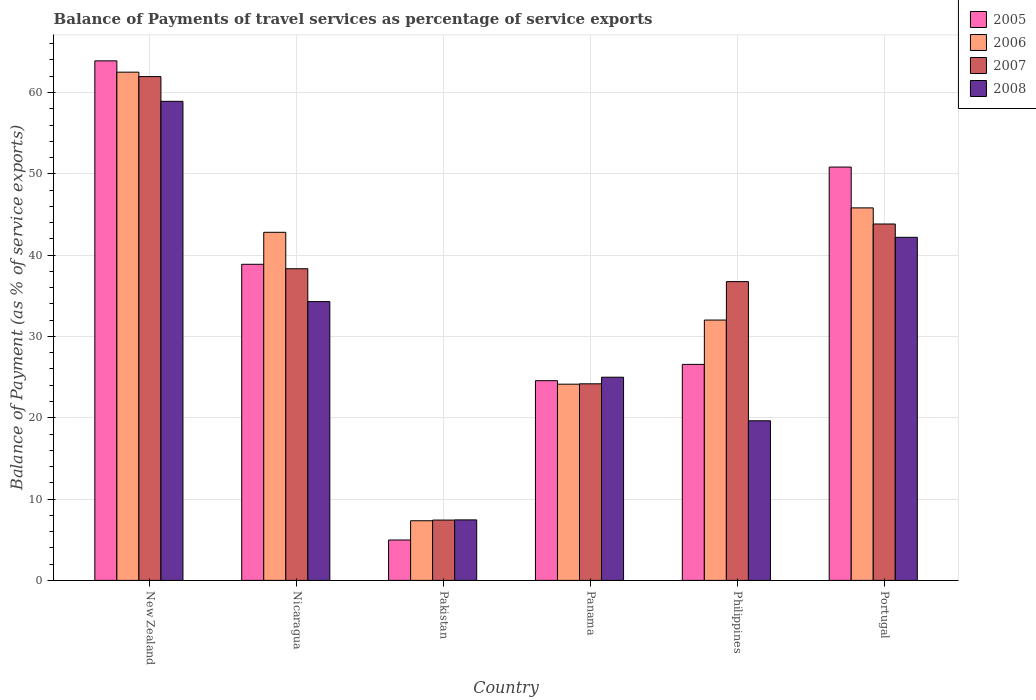How many different coloured bars are there?
Your answer should be very brief. 4. What is the label of the 3rd group of bars from the left?
Provide a short and direct response. Pakistan. In how many cases, is the number of bars for a given country not equal to the number of legend labels?
Provide a short and direct response. 0. What is the balance of payments of travel services in 2007 in Pakistan?
Your response must be concise. 7.42. Across all countries, what is the maximum balance of payments of travel services in 2008?
Ensure brevity in your answer.  58.91. Across all countries, what is the minimum balance of payments of travel services in 2006?
Provide a short and direct response. 7.34. In which country was the balance of payments of travel services in 2006 maximum?
Keep it short and to the point. New Zealand. What is the total balance of payments of travel services in 2007 in the graph?
Provide a succinct answer. 212.45. What is the difference between the balance of payments of travel services in 2006 in New Zealand and that in Panama?
Provide a short and direct response. 38.37. What is the difference between the balance of payments of travel services in 2008 in Panama and the balance of payments of travel services in 2007 in Portugal?
Provide a succinct answer. -18.84. What is the average balance of payments of travel services in 2006 per country?
Make the answer very short. 35.77. What is the difference between the balance of payments of travel services of/in 2007 and balance of payments of travel services of/in 2008 in Pakistan?
Your response must be concise. -0.02. In how many countries, is the balance of payments of travel services in 2008 greater than 20 %?
Keep it short and to the point. 4. What is the ratio of the balance of payments of travel services in 2007 in New Zealand to that in Panama?
Keep it short and to the point. 2.56. Is the balance of payments of travel services in 2005 in New Zealand less than that in Pakistan?
Your response must be concise. No. What is the difference between the highest and the second highest balance of payments of travel services in 2008?
Provide a short and direct response. 16.72. What is the difference between the highest and the lowest balance of payments of travel services in 2006?
Keep it short and to the point. 55.17. Is the sum of the balance of payments of travel services in 2006 in Nicaragua and Portugal greater than the maximum balance of payments of travel services in 2008 across all countries?
Ensure brevity in your answer.  Yes. Is it the case that in every country, the sum of the balance of payments of travel services in 2006 and balance of payments of travel services in 2008 is greater than the sum of balance of payments of travel services in 2007 and balance of payments of travel services in 2005?
Offer a very short reply. No. What does the 1st bar from the right in Panama represents?
Make the answer very short. 2008. How many bars are there?
Offer a very short reply. 24. Are all the bars in the graph horizontal?
Offer a very short reply. No. How many countries are there in the graph?
Give a very brief answer. 6. What is the difference between two consecutive major ticks on the Y-axis?
Your answer should be very brief. 10. Are the values on the major ticks of Y-axis written in scientific E-notation?
Offer a very short reply. No. Does the graph contain grids?
Give a very brief answer. Yes. Where does the legend appear in the graph?
Make the answer very short. Top right. How many legend labels are there?
Your answer should be very brief. 4. What is the title of the graph?
Provide a short and direct response. Balance of Payments of travel services as percentage of service exports. What is the label or title of the X-axis?
Provide a succinct answer. Country. What is the label or title of the Y-axis?
Keep it short and to the point. Balance of Payment (as % of service exports). What is the Balance of Payment (as % of service exports) of 2005 in New Zealand?
Your answer should be compact. 63.89. What is the Balance of Payment (as % of service exports) of 2006 in New Zealand?
Make the answer very short. 62.5. What is the Balance of Payment (as % of service exports) of 2007 in New Zealand?
Keep it short and to the point. 61.96. What is the Balance of Payment (as % of service exports) in 2008 in New Zealand?
Your response must be concise. 58.91. What is the Balance of Payment (as % of service exports) in 2005 in Nicaragua?
Offer a very short reply. 38.87. What is the Balance of Payment (as % of service exports) in 2006 in Nicaragua?
Your response must be concise. 42.81. What is the Balance of Payment (as % of service exports) in 2007 in Nicaragua?
Your answer should be compact. 38.33. What is the Balance of Payment (as % of service exports) in 2008 in Nicaragua?
Keep it short and to the point. 34.29. What is the Balance of Payment (as % of service exports) in 2005 in Pakistan?
Provide a succinct answer. 4.97. What is the Balance of Payment (as % of service exports) in 2006 in Pakistan?
Give a very brief answer. 7.34. What is the Balance of Payment (as % of service exports) in 2007 in Pakistan?
Provide a succinct answer. 7.42. What is the Balance of Payment (as % of service exports) in 2008 in Pakistan?
Keep it short and to the point. 7.44. What is the Balance of Payment (as % of service exports) of 2005 in Panama?
Give a very brief answer. 24.56. What is the Balance of Payment (as % of service exports) in 2006 in Panama?
Make the answer very short. 24.13. What is the Balance of Payment (as % of service exports) of 2007 in Panama?
Give a very brief answer. 24.18. What is the Balance of Payment (as % of service exports) in 2008 in Panama?
Offer a terse response. 24.99. What is the Balance of Payment (as % of service exports) of 2005 in Philippines?
Offer a terse response. 26.56. What is the Balance of Payment (as % of service exports) in 2006 in Philippines?
Provide a short and direct response. 32.02. What is the Balance of Payment (as % of service exports) in 2007 in Philippines?
Give a very brief answer. 36.74. What is the Balance of Payment (as % of service exports) of 2008 in Philippines?
Offer a terse response. 19.63. What is the Balance of Payment (as % of service exports) of 2005 in Portugal?
Ensure brevity in your answer.  50.83. What is the Balance of Payment (as % of service exports) in 2006 in Portugal?
Offer a terse response. 45.81. What is the Balance of Payment (as % of service exports) in 2007 in Portugal?
Provide a succinct answer. 43.83. What is the Balance of Payment (as % of service exports) in 2008 in Portugal?
Your response must be concise. 42.19. Across all countries, what is the maximum Balance of Payment (as % of service exports) of 2005?
Offer a terse response. 63.89. Across all countries, what is the maximum Balance of Payment (as % of service exports) of 2006?
Offer a very short reply. 62.5. Across all countries, what is the maximum Balance of Payment (as % of service exports) of 2007?
Offer a very short reply. 61.96. Across all countries, what is the maximum Balance of Payment (as % of service exports) of 2008?
Give a very brief answer. 58.91. Across all countries, what is the minimum Balance of Payment (as % of service exports) of 2005?
Ensure brevity in your answer.  4.97. Across all countries, what is the minimum Balance of Payment (as % of service exports) in 2006?
Ensure brevity in your answer.  7.34. Across all countries, what is the minimum Balance of Payment (as % of service exports) in 2007?
Your answer should be very brief. 7.42. Across all countries, what is the minimum Balance of Payment (as % of service exports) in 2008?
Make the answer very short. 7.44. What is the total Balance of Payment (as % of service exports) in 2005 in the graph?
Give a very brief answer. 209.69. What is the total Balance of Payment (as % of service exports) in 2006 in the graph?
Keep it short and to the point. 214.6. What is the total Balance of Payment (as % of service exports) of 2007 in the graph?
Make the answer very short. 212.45. What is the total Balance of Payment (as % of service exports) in 2008 in the graph?
Make the answer very short. 187.45. What is the difference between the Balance of Payment (as % of service exports) in 2005 in New Zealand and that in Nicaragua?
Provide a succinct answer. 25.02. What is the difference between the Balance of Payment (as % of service exports) of 2006 in New Zealand and that in Nicaragua?
Offer a terse response. 19.69. What is the difference between the Balance of Payment (as % of service exports) in 2007 in New Zealand and that in Nicaragua?
Provide a short and direct response. 23.63. What is the difference between the Balance of Payment (as % of service exports) of 2008 in New Zealand and that in Nicaragua?
Your answer should be very brief. 24.63. What is the difference between the Balance of Payment (as % of service exports) in 2005 in New Zealand and that in Pakistan?
Provide a succinct answer. 58.93. What is the difference between the Balance of Payment (as % of service exports) of 2006 in New Zealand and that in Pakistan?
Offer a very short reply. 55.17. What is the difference between the Balance of Payment (as % of service exports) of 2007 in New Zealand and that in Pakistan?
Your answer should be very brief. 54.54. What is the difference between the Balance of Payment (as % of service exports) in 2008 in New Zealand and that in Pakistan?
Your answer should be compact. 51.47. What is the difference between the Balance of Payment (as % of service exports) of 2005 in New Zealand and that in Panama?
Provide a short and direct response. 39.33. What is the difference between the Balance of Payment (as % of service exports) in 2006 in New Zealand and that in Panama?
Provide a short and direct response. 38.37. What is the difference between the Balance of Payment (as % of service exports) of 2007 in New Zealand and that in Panama?
Your response must be concise. 37.78. What is the difference between the Balance of Payment (as % of service exports) of 2008 in New Zealand and that in Panama?
Your answer should be very brief. 33.93. What is the difference between the Balance of Payment (as % of service exports) of 2005 in New Zealand and that in Philippines?
Your answer should be compact. 37.33. What is the difference between the Balance of Payment (as % of service exports) in 2006 in New Zealand and that in Philippines?
Your answer should be very brief. 30.49. What is the difference between the Balance of Payment (as % of service exports) in 2007 in New Zealand and that in Philippines?
Your answer should be compact. 25.21. What is the difference between the Balance of Payment (as % of service exports) in 2008 in New Zealand and that in Philippines?
Offer a very short reply. 39.29. What is the difference between the Balance of Payment (as % of service exports) in 2005 in New Zealand and that in Portugal?
Provide a short and direct response. 13.06. What is the difference between the Balance of Payment (as % of service exports) of 2006 in New Zealand and that in Portugal?
Provide a succinct answer. 16.69. What is the difference between the Balance of Payment (as % of service exports) of 2007 in New Zealand and that in Portugal?
Your response must be concise. 18.13. What is the difference between the Balance of Payment (as % of service exports) of 2008 in New Zealand and that in Portugal?
Offer a very short reply. 16.72. What is the difference between the Balance of Payment (as % of service exports) of 2005 in Nicaragua and that in Pakistan?
Your answer should be very brief. 33.91. What is the difference between the Balance of Payment (as % of service exports) in 2006 in Nicaragua and that in Pakistan?
Your answer should be compact. 35.47. What is the difference between the Balance of Payment (as % of service exports) of 2007 in Nicaragua and that in Pakistan?
Provide a succinct answer. 30.91. What is the difference between the Balance of Payment (as % of service exports) of 2008 in Nicaragua and that in Pakistan?
Make the answer very short. 26.85. What is the difference between the Balance of Payment (as % of service exports) of 2005 in Nicaragua and that in Panama?
Your answer should be compact. 14.31. What is the difference between the Balance of Payment (as % of service exports) of 2006 in Nicaragua and that in Panama?
Give a very brief answer. 18.68. What is the difference between the Balance of Payment (as % of service exports) in 2007 in Nicaragua and that in Panama?
Your answer should be very brief. 14.15. What is the difference between the Balance of Payment (as % of service exports) in 2008 in Nicaragua and that in Panama?
Your answer should be compact. 9.3. What is the difference between the Balance of Payment (as % of service exports) in 2005 in Nicaragua and that in Philippines?
Ensure brevity in your answer.  12.31. What is the difference between the Balance of Payment (as % of service exports) in 2006 in Nicaragua and that in Philippines?
Your answer should be compact. 10.79. What is the difference between the Balance of Payment (as % of service exports) in 2007 in Nicaragua and that in Philippines?
Give a very brief answer. 1.58. What is the difference between the Balance of Payment (as % of service exports) of 2008 in Nicaragua and that in Philippines?
Offer a terse response. 14.66. What is the difference between the Balance of Payment (as % of service exports) in 2005 in Nicaragua and that in Portugal?
Your answer should be very brief. -11.96. What is the difference between the Balance of Payment (as % of service exports) in 2006 in Nicaragua and that in Portugal?
Your response must be concise. -3. What is the difference between the Balance of Payment (as % of service exports) in 2007 in Nicaragua and that in Portugal?
Offer a very short reply. -5.5. What is the difference between the Balance of Payment (as % of service exports) of 2008 in Nicaragua and that in Portugal?
Your response must be concise. -7.9. What is the difference between the Balance of Payment (as % of service exports) in 2005 in Pakistan and that in Panama?
Give a very brief answer. -19.59. What is the difference between the Balance of Payment (as % of service exports) of 2006 in Pakistan and that in Panama?
Offer a terse response. -16.79. What is the difference between the Balance of Payment (as % of service exports) in 2007 in Pakistan and that in Panama?
Your answer should be very brief. -16.76. What is the difference between the Balance of Payment (as % of service exports) of 2008 in Pakistan and that in Panama?
Give a very brief answer. -17.55. What is the difference between the Balance of Payment (as % of service exports) of 2005 in Pakistan and that in Philippines?
Your response must be concise. -21.6. What is the difference between the Balance of Payment (as % of service exports) of 2006 in Pakistan and that in Philippines?
Provide a short and direct response. -24.68. What is the difference between the Balance of Payment (as % of service exports) in 2007 in Pakistan and that in Philippines?
Ensure brevity in your answer.  -29.33. What is the difference between the Balance of Payment (as % of service exports) in 2008 in Pakistan and that in Philippines?
Keep it short and to the point. -12.19. What is the difference between the Balance of Payment (as % of service exports) of 2005 in Pakistan and that in Portugal?
Provide a short and direct response. -45.86. What is the difference between the Balance of Payment (as % of service exports) in 2006 in Pakistan and that in Portugal?
Provide a short and direct response. -38.47. What is the difference between the Balance of Payment (as % of service exports) in 2007 in Pakistan and that in Portugal?
Ensure brevity in your answer.  -36.41. What is the difference between the Balance of Payment (as % of service exports) of 2008 in Pakistan and that in Portugal?
Provide a succinct answer. -34.75. What is the difference between the Balance of Payment (as % of service exports) of 2005 in Panama and that in Philippines?
Ensure brevity in your answer.  -2. What is the difference between the Balance of Payment (as % of service exports) in 2006 in Panama and that in Philippines?
Your answer should be compact. -7.88. What is the difference between the Balance of Payment (as % of service exports) of 2007 in Panama and that in Philippines?
Your response must be concise. -12.57. What is the difference between the Balance of Payment (as % of service exports) of 2008 in Panama and that in Philippines?
Provide a short and direct response. 5.36. What is the difference between the Balance of Payment (as % of service exports) in 2005 in Panama and that in Portugal?
Offer a terse response. -26.27. What is the difference between the Balance of Payment (as % of service exports) of 2006 in Panama and that in Portugal?
Your answer should be very brief. -21.68. What is the difference between the Balance of Payment (as % of service exports) in 2007 in Panama and that in Portugal?
Give a very brief answer. -19.65. What is the difference between the Balance of Payment (as % of service exports) of 2008 in Panama and that in Portugal?
Provide a succinct answer. -17.2. What is the difference between the Balance of Payment (as % of service exports) in 2005 in Philippines and that in Portugal?
Make the answer very short. -24.27. What is the difference between the Balance of Payment (as % of service exports) in 2006 in Philippines and that in Portugal?
Make the answer very short. -13.8. What is the difference between the Balance of Payment (as % of service exports) of 2007 in Philippines and that in Portugal?
Offer a terse response. -7.09. What is the difference between the Balance of Payment (as % of service exports) in 2008 in Philippines and that in Portugal?
Offer a very short reply. -22.56. What is the difference between the Balance of Payment (as % of service exports) in 2005 in New Zealand and the Balance of Payment (as % of service exports) in 2006 in Nicaragua?
Offer a very short reply. 21.09. What is the difference between the Balance of Payment (as % of service exports) of 2005 in New Zealand and the Balance of Payment (as % of service exports) of 2007 in Nicaragua?
Keep it short and to the point. 25.57. What is the difference between the Balance of Payment (as % of service exports) in 2005 in New Zealand and the Balance of Payment (as % of service exports) in 2008 in Nicaragua?
Provide a short and direct response. 29.61. What is the difference between the Balance of Payment (as % of service exports) of 2006 in New Zealand and the Balance of Payment (as % of service exports) of 2007 in Nicaragua?
Keep it short and to the point. 24.18. What is the difference between the Balance of Payment (as % of service exports) of 2006 in New Zealand and the Balance of Payment (as % of service exports) of 2008 in Nicaragua?
Offer a terse response. 28.21. What is the difference between the Balance of Payment (as % of service exports) of 2007 in New Zealand and the Balance of Payment (as % of service exports) of 2008 in Nicaragua?
Make the answer very short. 27.67. What is the difference between the Balance of Payment (as % of service exports) of 2005 in New Zealand and the Balance of Payment (as % of service exports) of 2006 in Pakistan?
Offer a very short reply. 56.56. What is the difference between the Balance of Payment (as % of service exports) in 2005 in New Zealand and the Balance of Payment (as % of service exports) in 2007 in Pakistan?
Provide a succinct answer. 56.47. What is the difference between the Balance of Payment (as % of service exports) in 2005 in New Zealand and the Balance of Payment (as % of service exports) in 2008 in Pakistan?
Offer a terse response. 56.45. What is the difference between the Balance of Payment (as % of service exports) of 2006 in New Zealand and the Balance of Payment (as % of service exports) of 2007 in Pakistan?
Provide a succinct answer. 55.08. What is the difference between the Balance of Payment (as % of service exports) in 2006 in New Zealand and the Balance of Payment (as % of service exports) in 2008 in Pakistan?
Give a very brief answer. 55.06. What is the difference between the Balance of Payment (as % of service exports) in 2007 in New Zealand and the Balance of Payment (as % of service exports) in 2008 in Pakistan?
Offer a very short reply. 54.52. What is the difference between the Balance of Payment (as % of service exports) of 2005 in New Zealand and the Balance of Payment (as % of service exports) of 2006 in Panama?
Your answer should be compact. 39.76. What is the difference between the Balance of Payment (as % of service exports) in 2005 in New Zealand and the Balance of Payment (as % of service exports) in 2007 in Panama?
Offer a very short reply. 39.72. What is the difference between the Balance of Payment (as % of service exports) of 2005 in New Zealand and the Balance of Payment (as % of service exports) of 2008 in Panama?
Offer a very short reply. 38.9. What is the difference between the Balance of Payment (as % of service exports) in 2006 in New Zealand and the Balance of Payment (as % of service exports) in 2007 in Panama?
Provide a succinct answer. 38.33. What is the difference between the Balance of Payment (as % of service exports) in 2006 in New Zealand and the Balance of Payment (as % of service exports) in 2008 in Panama?
Keep it short and to the point. 37.51. What is the difference between the Balance of Payment (as % of service exports) of 2007 in New Zealand and the Balance of Payment (as % of service exports) of 2008 in Panama?
Give a very brief answer. 36.97. What is the difference between the Balance of Payment (as % of service exports) in 2005 in New Zealand and the Balance of Payment (as % of service exports) in 2006 in Philippines?
Offer a terse response. 31.88. What is the difference between the Balance of Payment (as % of service exports) of 2005 in New Zealand and the Balance of Payment (as % of service exports) of 2007 in Philippines?
Your response must be concise. 27.15. What is the difference between the Balance of Payment (as % of service exports) in 2005 in New Zealand and the Balance of Payment (as % of service exports) in 2008 in Philippines?
Provide a succinct answer. 44.26. What is the difference between the Balance of Payment (as % of service exports) in 2006 in New Zealand and the Balance of Payment (as % of service exports) in 2007 in Philippines?
Give a very brief answer. 25.76. What is the difference between the Balance of Payment (as % of service exports) in 2006 in New Zealand and the Balance of Payment (as % of service exports) in 2008 in Philippines?
Ensure brevity in your answer.  42.87. What is the difference between the Balance of Payment (as % of service exports) in 2007 in New Zealand and the Balance of Payment (as % of service exports) in 2008 in Philippines?
Offer a terse response. 42.33. What is the difference between the Balance of Payment (as % of service exports) in 2005 in New Zealand and the Balance of Payment (as % of service exports) in 2006 in Portugal?
Keep it short and to the point. 18.08. What is the difference between the Balance of Payment (as % of service exports) of 2005 in New Zealand and the Balance of Payment (as % of service exports) of 2007 in Portugal?
Ensure brevity in your answer.  20.06. What is the difference between the Balance of Payment (as % of service exports) in 2005 in New Zealand and the Balance of Payment (as % of service exports) in 2008 in Portugal?
Provide a short and direct response. 21.7. What is the difference between the Balance of Payment (as % of service exports) of 2006 in New Zealand and the Balance of Payment (as % of service exports) of 2007 in Portugal?
Your answer should be compact. 18.67. What is the difference between the Balance of Payment (as % of service exports) of 2006 in New Zealand and the Balance of Payment (as % of service exports) of 2008 in Portugal?
Provide a succinct answer. 20.31. What is the difference between the Balance of Payment (as % of service exports) of 2007 in New Zealand and the Balance of Payment (as % of service exports) of 2008 in Portugal?
Provide a short and direct response. 19.77. What is the difference between the Balance of Payment (as % of service exports) of 2005 in Nicaragua and the Balance of Payment (as % of service exports) of 2006 in Pakistan?
Ensure brevity in your answer.  31.54. What is the difference between the Balance of Payment (as % of service exports) of 2005 in Nicaragua and the Balance of Payment (as % of service exports) of 2007 in Pakistan?
Make the answer very short. 31.46. What is the difference between the Balance of Payment (as % of service exports) in 2005 in Nicaragua and the Balance of Payment (as % of service exports) in 2008 in Pakistan?
Offer a terse response. 31.43. What is the difference between the Balance of Payment (as % of service exports) in 2006 in Nicaragua and the Balance of Payment (as % of service exports) in 2007 in Pakistan?
Offer a very short reply. 35.39. What is the difference between the Balance of Payment (as % of service exports) in 2006 in Nicaragua and the Balance of Payment (as % of service exports) in 2008 in Pakistan?
Make the answer very short. 35.37. What is the difference between the Balance of Payment (as % of service exports) of 2007 in Nicaragua and the Balance of Payment (as % of service exports) of 2008 in Pakistan?
Ensure brevity in your answer.  30.89. What is the difference between the Balance of Payment (as % of service exports) in 2005 in Nicaragua and the Balance of Payment (as % of service exports) in 2006 in Panama?
Provide a short and direct response. 14.74. What is the difference between the Balance of Payment (as % of service exports) in 2005 in Nicaragua and the Balance of Payment (as % of service exports) in 2007 in Panama?
Your response must be concise. 14.7. What is the difference between the Balance of Payment (as % of service exports) in 2005 in Nicaragua and the Balance of Payment (as % of service exports) in 2008 in Panama?
Keep it short and to the point. 13.89. What is the difference between the Balance of Payment (as % of service exports) in 2006 in Nicaragua and the Balance of Payment (as % of service exports) in 2007 in Panama?
Your response must be concise. 18.63. What is the difference between the Balance of Payment (as % of service exports) in 2006 in Nicaragua and the Balance of Payment (as % of service exports) in 2008 in Panama?
Give a very brief answer. 17.82. What is the difference between the Balance of Payment (as % of service exports) of 2007 in Nicaragua and the Balance of Payment (as % of service exports) of 2008 in Panama?
Make the answer very short. 13.34. What is the difference between the Balance of Payment (as % of service exports) of 2005 in Nicaragua and the Balance of Payment (as % of service exports) of 2006 in Philippines?
Provide a succinct answer. 6.86. What is the difference between the Balance of Payment (as % of service exports) of 2005 in Nicaragua and the Balance of Payment (as % of service exports) of 2007 in Philippines?
Provide a succinct answer. 2.13. What is the difference between the Balance of Payment (as % of service exports) in 2005 in Nicaragua and the Balance of Payment (as % of service exports) in 2008 in Philippines?
Your response must be concise. 19.24. What is the difference between the Balance of Payment (as % of service exports) in 2006 in Nicaragua and the Balance of Payment (as % of service exports) in 2007 in Philippines?
Ensure brevity in your answer.  6.06. What is the difference between the Balance of Payment (as % of service exports) in 2006 in Nicaragua and the Balance of Payment (as % of service exports) in 2008 in Philippines?
Make the answer very short. 23.18. What is the difference between the Balance of Payment (as % of service exports) in 2007 in Nicaragua and the Balance of Payment (as % of service exports) in 2008 in Philippines?
Make the answer very short. 18.7. What is the difference between the Balance of Payment (as % of service exports) of 2005 in Nicaragua and the Balance of Payment (as % of service exports) of 2006 in Portugal?
Your answer should be compact. -6.94. What is the difference between the Balance of Payment (as % of service exports) in 2005 in Nicaragua and the Balance of Payment (as % of service exports) in 2007 in Portugal?
Keep it short and to the point. -4.96. What is the difference between the Balance of Payment (as % of service exports) of 2005 in Nicaragua and the Balance of Payment (as % of service exports) of 2008 in Portugal?
Provide a succinct answer. -3.32. What is the difference between the Balance of Payment (as % of service exports) in 2006 in Nicaragua and the Balance of Payment (as % of service exports) in 2007 in Portugal?
Ensure brevity in your answer.  -1.02. What is the difference between the Balance of Payment (as % of service exports) in 2006 in Nicaragua and the Balance of Payment (as % of service exports) in 2008 in Portugal?
Offer a very short reply. 0.62. What is the difference between the Balance of Payment (as % of service exports) in 2007 in Nicaragua and the Balance of Payment (as % of service exports) in 2008 in Portugal?
Your answer should be compact. -3.86. What is the difference between the Balance of Payment (as % of service exports) in 2005 in Pakistan and the Balance of Payment (as % of service exports) in 2006 in Panama?
Your answer should be very brief. -19.16. What is the difference between the Balance of Payment (as % of service exports) of 2005 in Pakistan and the Balance of Payment (as % of service exports) of 2007 in Panama?
Give a very brief answer. -19.21. What is the difference between the Balance of Payment (as % of service exports) in 2005 in Pakistan and the Balance of Payment (as % of service exports) in 2008 in Panama?
Give a very brief answer. -20.02. What is the difference between the Balance of Payment (as % of service exports) of 2006 in Pakistan and the Balance of Payment (as % of service exports) of 2007 in Panama?
Your response must be concise. -16.84. What is the difference between the Balance of Payment (as % of service exports) of 2006 in Pakistan and the Balance of Payment (as % of service exports) of 2008 in Panama?
Make the answer very short. -17.65. What is the difference between the Balance of Payment (as % of service exports) in 2007 in Pakistan and the Balance of Payment (as % of service exports) in 2008 in Panama?
Ensure brevity in your answer.  -17.57. What is the difference between the Balance of Payment (as % of service exports) of 2005 in Pakistan and the Balance of Payment (as % of service exports) of 2006 in Philippines?
Provide a short and direct response. -27.05. What is the difference between the Balance of Payment (as % of service exports) of 2005 in Pakistan and the Balance of Payment (as % of service exports) of 2007 in Philippines?
Provide a short and direct response. -31.78. What is the difference between the Balance of Payment (as % of service exports) in 2005 in Pakistan and the Balance of Payment (as % of service exports) in 2008 in Philippines?
Offer a terse response. -14.66. What is the difference between the Balance of Payment (as % of service exports) of 2006 in Pakistan and the Balance of Payment (as % of service exports) of 2007 in Philippines?
Your answer should be compact. -29.41. What is the difference between the Balance of Payment (as % of service exports) in 2006 in Pakistan and the Balance of Payment (as % of service exports) in 2008 in Philippines?
Your answer should be very brief. -12.29. What is the difference between the Balance of Payment (as % of service exports) in 2007 in Pakistan and the Balance of Payment (as % of service exports) in 2008 in Philippines?
Your answer should be very brief. -12.21. What is the difference between the Balance of Payment (as % of service exports) of 2005 in Pakistan and the Balance of Payment (as % of service exports) of 2006 in Portugal?
Provide a succinct answer. -40.84. What is the difference between the Balance of Payment (as % of service exports) in 2005 in Pakistan and the Balance of Payment (as % of service exports) in 2007 in Portugal?
Your response must be concise. -38.86. What is the difference between the Balance of Payment (as % of service exports) of 2005 in Pakistan and the Balance of Payment (as % of service exports) of 2008 in Portugal?
Provide a succinct answer. -37.22. What is the difference between the Balance of Payment (as % of service exports) of 2006 in Pakistan and the Balance of Payment (as % of service exports) of 2007 in Portugal?
Offer a terse response. -36.49. What is the difference between the Balance of Payment (as % of service exports) in 2006 in Pakistan and the Balance of Payment (as % of service exports) in 2008 in Portugal?
Provide a succinct answer. -34.85. What is the difference between the Balance of Payment (as % of service exports) in 2007 in Pakistan and the Balance of Payment (as % of service exports) in 2008 in Portugal?
Provide a short and direct response. -34.77. What is the difference between the Balance of Payment (as % of service exports) of 2005 in Panama and the Balance of Payment (as % of service exports) of 2006 in Philippines?
Ensure brevity in your answer.  -7.46. What is the difference between the Balance of Payment (as % of service exports) of 2005 in Panama and the Balance of Payment (as % of service exports) of 2007 in Philippines?
Ensure brevity in your answer.  -12.18. What is the difference between the Balance of Payment (as % of service exports) in 2005 in Panama and the Balance of Payment (as % of service exports) in 2008 in Philippines?
Your response must be concise. 4.93. What is the difference between the Balance of Payment (as % of service exports) in 2006 in Panama and the Balance of Payment (as % of service exports) in 2007 in Philippines?
Provide a short and direct response. -12.61. What is the difference between the Balance of Payment (as % of service exports) in 2006 in Panama and the Balance of Payment (as % of service exports) in 2008 in Philippines?
Your answer should be very brief. 4.5. What is the difference between the Balance of Payment (as % of service exports) of 2007 in Panama and the Balance of Payment (as % of service exports) of 2008 in Philippines?
Keep it short and to the point. 4.55. What is the difference between the Balance of Payment (as % of service exports) of 2005 in Panama and the Balance of Payment (as % of service exports) of 2006 in Portugal?
Make the answer very short. -21.25. What is the difference between the Balance of Payment (as % of service exports) of 2005 in Panama and the Balance of Payment (as % of service exports) of 2007 in Portugal?
Make the answer very short. -19.27. What is the difference between the Balance of Payment (as % of service exports) of 2005 in Panama and the Balance of Payment (as % of service exports) of 2008 in Portugal?
Give a very brief answer. -17.63. What is the difference between the Balance of Payment (as % of service exports) in 2006 in Panama and the Balance of Payment (as % of service exports) in 2007 in Portugal?
Give a very brief answer. -19.7. What is the difference between the Balance of Payment (as % of service exports) of 2006 in Panama and the Balance of Payment (as % of service exports) of 2008 in Portugal?
Give a very brief answer. -18.06. What is the difference between the Balance of Payment (as % of service exports) of 2007 in Panama and the Balance of Payment (as % of service exports) of 2008 in Portugal?
Offer a terse response. -18.02. What is the difference between the Balance of Payment (as % of service exports) in 2005 in Philippines and the Balance of Payment (as % of service exports) in 2006 in Portugal?
Your answer should be compact. -19.25. What is the difference between the Balance of Payment (as % of service exports) of 2005 in Philippines and the Balance of Payment (as % of service exports) of 2007 in Portugal?
Make the answer very short. -17.27. What is the difference between the Balance of Payment (as % of service exports) in 2005 in Philippines and the Balance of Payment (as % of service exports) in 2008 in Portugal?
Your response must be concise. -15.63. What is the difference between the Balance of Payment (as % of service exports) of 2006 in Philippines and the Balance of Payment (as % of service exports) of 2007 in Portugal?
Offer a terse response. -11.81. What is the difference between the Balance of Payment (as % of service exports) of 2006 in Philippines and the Balance of Payment (as % of service exports) of 2008 in Portugal?
Provide a succinct answer. -10.18. What is the difference between the Balance of Payment (as % of service exports) of 2007 in Philippines and the Balance of Payment (as % of service exports) of 2008 in Portugal?
Provide a succinct answer. -5.45. What is the average Balance of Payment (as % of service exports) of 2005 per country?
Offer a very short reply. 34.95. What is the average Balance of Payment (as % of service exports) in 2006 per country?
Keep it short and to the point. 35.77. What is the average Balance of Payment (as % of service exports) in 2007 per country?
Make the answer very short. 35.41. What is the average Balance of Payment (as % of service exports) in 2008 per country?
Keep it short and to the point. 31.24. What is the difference between the Balance of Payment (as % of service exports) of 2005 and Balance of Payment (as % of service exports) of 2006 in New Zealand?
Ensure brevity in your answer.  1.39. What is the difference between the Balance of Payment (as % of service exports) in 2005 and Balance of Payment (as % of service exports) in 2007 in New Zealand?
Provide a succinct answer. 1.93. What is the difference between the Balance of Payment (as % of service exports) of 2005 and Balance of Payment (as % of service exports) of 2008 in New Zealand?
Your answer should be compact. 4.98. What is the difference between the Balance of Payment (as % of service exports) of 2006 and Balance of Payment (as % of service exports) of 2007 in New Zealand?
Your response must be concise. 0.54. What is the difference between the Balance of Payment (as % of service exports) in 2006 and Balance of Payment (as % of service exports) in 2008 in New Zealand?
Ensure brevity in your answer.  3.59. What is the difference between the Balance of Payment (as % of service exports) in 2007 and Balance of Payment (as % of service exports) in 2008 in New Zealand?
Offer a terse response. 3.04. What is the difference between the Balance of Payment (as % of service exports) of 2005 and Balance of Payment (as % of service exports) of 2006 in Nicaragua?
Keep it short and to the point. -3.93. What is the difference between the Balance of Payment (as % of service exports) in 2005 and Balance of Payment (as % of service exports) in 2007 in Nicaragua?
Ensure brevity in your answer.  0.55. What is the difference between the Balance of Payment (as % of service exports) in 2005 and Balance of Payment (as % of service exports) in 2008 in Nicaragua?
Provide a succinct answer. 4.59. What is the difference between the Balance of Payment (as % of service exports) in 2006 and Balance of Payment (as % of service exports) in 2007 in Nicaragua?
Your answer should be compact. 4.48. What is the difference between the Balance of Payment (as % of service exports) of 2006 and Balance of Payment (as % of service exports) of 2008 in Nicaragua?
Give a very brief answer. 8.52. What is the difference between the Balance of Payment (as % of service exports) of 2007 and Balance of Payment (as % of service exports) of 2008 in Nicaragua?
Keep it short and to the point. 4.04. What is the difference between the Balance of Payment (as % of service exports) in 2005 and Balance of Payment (as % of service exports) in 2006 in Pakistan?
Your answer should be very brief. -2.37. What is the difference between the Balance of Payment (as % of service exports) of 2005 and Balance of Payment (as % of service exports) of 2007 in Pakistan?
Keep it short and to the point. -2.45. What is the difference between the Balance of Payment (as % of service exports) of 2005 and Balance of Payment (as % of service exports) of 2008 in Pakistan?
Give a very brief answer. -2.47. What is the difference between the Balance of Payment (as % of service exports) of 2006 and Balance of Payment (as % of service exports) of 2007 in Pakistan?
Ensure brevity in your answer.  -0.08. What is the difference between the Balance of Payment (as % of service exports) in 2006 and Balance of Payment (as % of service exports) in 2008 in Pakistan?
Offer a very short reply. -0.1. What is the difference between the Balance of Payment (as % of service exports) of 2007 and Balance of Payment (as % of service exports) of 2008 in Pakistan?
Your answer should be compact. -0.02. What is the difference between the Balance of Payment (as % of service exports) of 2005 and Balance of Payment (as % of service exports) of 2006 in Panama?
Offer a very short reply. 0.43. What is the difference between the Balance of Payment (as % of service exports) in 2005 and Balance of Payment (as % of service exports) in 2007 in Panama?
Provide a short and direct response. 0.38. What is the difference between the Balance of Payment (as % of service exports) in 2005 and Balance of Payment (as % of service exports) in 2008 in Panama?
Provide a succinct answer. -0.43. What is the difference between the Balance of Payment (as % of service exports) in 2006 and Balance of Payment (as % of service exports) in 2007 in Panama?
Ensure brevity in your answer.  -0.04. What is the difference between the Balance of Payment (as % of service exports) in 2006 and Balance of Payment (as % of service exports) in 2008 in Panama?
Your answer should be compact. -0.86. What is the difference between the Balance of Payment (as % of service exports) in 2007 and Balance of Payment (as % of service exports) in 2008 in Panama?
Your answer should be compact. -0.81. What is the difference between the Balance of Payment (as % of service exports) of 2005 and Balance of Payment (as % of service exports) of 2006 in Philippines?
Your answer should be compact. -5.45. What is the difference between the Balance of Payment (as % of service exports) in 2005 and Balance of Payment (as % of service exports) in 2007 in Philippines?
Keep it short and to the point. -10.18. What is the difference between the Balance of Payment (as % of service exports) of 2005 and Balance of Payment (as % of service exports) of 2008 in Philippines?
Your answer should be very brief. 6.93. What is the difference between the Balance of Payment (as % of service exports) in 2006 and Balance of Payment (as % of service exports) in 2007 in Philippines?
Your response must be concise. -4.73. What is the difference between the Balance of Payment (as % of service exports) in 2006 and Balance of Payment (as % of service exports) in 2008 in Philippines?
Your answer should be compact. 12.39. What is the difference between the Balance of Payment (as % of service exports) of 2007 and Balance of Payment (as % of service exports) of 2008 in Philippines?
Give a very brief answer. 17.11. What is the difference between the Balance of Payment (as % of service exports) in 2005 and Balance of Payment (as % of service exports) in 2006 in Portugal?
Provide a short and direct response. 5.02. What is the difference between the Balance of Payment (as % of service exports) in 2005 and Balance of Payment (as % of service exports) in 2007 in Portugal?
Keep it short and to the point. 7. What is the difference between the Balance of Payment (as % of service exports) of 2005 and Balance of Payment (as % of service exports) of 2008 in Portugal?
Ensure brevity in your answer.  8.64. What is the difference between the Balance of Payment (as % of service exports) of 2006 and Balance of Payment (as % of service exports) of 2007 in Portugal?
Give a very brief answer. 1.98. What is the difference between the Balance of Payment (as % of service exports) in 2006 and Balance of Payment (as % of service exports) in 2008 in Portugal?
Your response must be concise. 3.62. What is the difference between the Balance of Payment (as % of service exports) in 2007 and Balance of Payment (as % of service exports) in 2008 in Portugal?
Ensure brevity in your answer.  1.64. What is the ratio of the Balance of Payment (as % of service exports) of 2005 in New Zealand to that in Nicaragua?
Offer a terse response. 1.64. What is the ratio of the Balance of Payment (as % of service exports) in 2006 in New Zealand to that in Nicaragua?
Your answer should be compact. 1.46. What is the ratio of the Balance of Payment (as % of service exports) in 2007 in New Zealand to that in Nicaragua?
Provide a succinct answer. 1.62. What is the ratio of the Balance of Payment (as % of service exports) of 2008 in New Zealand to that in Nicaragua?
Provide a short and direct response. 1.72. What is the ratio of the Balance of Payment (as % of service exports) of 2005 in New Zealand to that in Pakistan?
Offer a very short reply. 12.87. What is the ratio of the Balance of Payment (as % of service exports) in 2006 in New Zealand to that in Pakistan?
Offer a terse response. 8.52. What is the ratio of the Balance of Payment (as % of service exports) of 2007 in New Zealand to that in Pakistan?
Make the answer very short. 8.35. What is the ratio of the Balance of Payment (as % of service exports) of 2008 in New Zealand to that in Pakistan?
Your answer should be compact. 7.92. What is the ratio of the Balance of Payment (as % of service exports) in 2005 in New Zealand to that in Panama?
Offer a very short reply. 2.6. What is the ratio of the Balance of Payment (as % of service exports) in 2006 in New Zealand to that in Panama?
Make the answer very short. 2.59. What is the ratio of the Balance of Payment (as % of service exports) of 2007 in New Zealand to that in Panama?
Provide a short and direct response. 2.56. What is the ratio of the Balance of Payment (as % of service exports) in 2008 in New Zealand to that in Panama?
Offer a terse response. 2.36. What is the ratio of the Balance of Payment (as % of service exports) of 2005 in New Zealand to that in Philippines?
Offer a very short reply. 2.41. What is the ratio of the Balance of Payment (as % of service exports) in 2006 in New Zealand to that in Philippines?
Offer a very short reply. 1.95. What is the ratio of the Balance of Payment (as % of service exports) of 2007 in New Zealand to that in Philippines?
Provide a short and direct response. 1.69. What is the ratio of the Balance of Payment (as % of service exports) in 2008 in New Zealand to that in Philippines?
Ensure brevity in your answer.  3. What is the ratio of the Balance of Payment (as % of service exports) of 2005 in New Zealand to that in Portugal?
Provide a short and direct response. 1.26. What is the ratio of the Balance of Payment (as % of service exports) in 2006 in New Zealand to that in Portugal?
Your answer should be compact. 1.36. What is the ratio of the Balance of Payment (as % of service exports) in 2007 in New Zealand to that in Portugal?
Your answer should be compact. 1.41. What is the ratio of the Balance of Payment (as % of service exports) in 2008 in New Zealand to that in Portugal?
Your answer should be very brief. 1.4. What is the ratio of the Balance of Payment (as % of service exports) in 2005 in Nicaragua to that in Pakistan?
Offer a very short reply. 7.83. What is the ratio of the Balance of Payment (as % of service exports) in 2006 in Nicaragua to that in Pakistan?
Offer a very short reply. 5.84. What is the ratio of the Balance of Payment (as % of service exports) in 2007 in Nicaragua to that in Pakistan?
Give a very brief answer. 5.17. What is the ratio of the Balance of Payment (as % of service exports) of 2008 in Nicaragua to that in Pakistan?
Offer a very short reply. 4.61. What is the ratio of the Balance of Payment (as % of service exports) in 2005 in Nicaragua to that in Panama?
Ensure brevity in your answer.  1.58. What is the ratio of the Balance of Payment (as % of service exports) in 2006 in Nicaragua to that in Panama?
Give a very brief answer. 1.77. What is the ratio of the Balance of Payment (as % of service exports) of 2007 in Nicaragua to that in Panama?
Provide a succinct answer. 1.59. What is the ratio of the Balance of Payment (as % of service exports) in 2008 in Nicaragua to that in Panama?
Make the answer very short. 1.37. What is the ratio of the Balance of Payment (as % of service exports) in 2005 in Nicaragua to that in Philippines?
Give a very brief answer. 1.46. What is the ratio of the Balance of Payment (as % of service exports) of 2006 in Nicaragua to that in Philippines?
Give a very brief answer. 1.34. What is the ratio of the Balance of Payment (as % of service exports) in 2007 in Nicaragua to that in Philippines?
Ensure brevity in your answer.  1.04. What is the ratio of the Balance of Payment (as % of service exports) in 2008 in Nicaragua to that in Philippines?
Ensure brevity in your answer.  1.75. What is the ratio of the Balance of Payment (as % of service exports) in 2005 in Nicaragua to that in Portugal?
Offer a terse response. 0.76. What is the ratio of the Balance of Payment (as % of service exports) in 2006 in Nicaragua to that in Portugal?
Provide a short and direct response. 0.93. What is the ratio of the Balance of Payment (as % of service exports) in 2007 in Nicaragua to that in Portugal?
Offer a terse response. 0.87. What is the ratio of the Balance of Payment (as % of service exports) of 2008 in Nicaragua to that in Portugal?
Offer a terse response. 0.81. What is the ratio of the Balance of Payment (as % of service exports) of 2005 in Pakistan to that in Panama?
Give a very brief answer. 0.2. What is the ratio of the Balance of Payment (as % of service exports) of 2006 in Pakistan to that in Panama?
Your answer should be very brief. 0.3. What is the ratio of the Balance of Payment (as % of service exports) of 2007 in Pakistan to that in Panama?
Provide a short and direct response. 0.31. What is the ratio of the Balance of Payment (as % of service exports) of 2008 in Pakistan to that in Panama?
Your answer should be very brief. 0.3. What is the ratio of the Balance of Payment (as % of service exports) of 2005 in Pakistan to that in Philippines?
Provide a short and direct response. 0.19. What is the ratio of the Balance of Payment (as % of service exports) of 2006 in Pakistan to that in Philippines?
Ensure brevity in your answer.  0.23. What is the ratio of the Balance of Payment (as % of service exports) of 2007 in Pakistan to that in Philippines?
Keep it short and to the point. 0.2. What is the ratio of the Balance of Payment (as % of service exports) in 2008 in Pakistan to that in Philippines?
Provide a short and direct response. 0.38. What is the ratio of the Balance of Payment (as % of service exports) of 2005 in Pakistan to that in Portugal?
Ensure brevity in your answer.  0.1. What is the ratio of the Balance of Payment (as % of service exports) in 2006 in Pakistan to that in Portugal?
Give a very brief answer. 0.16. What is the ratio of the Balance of Payment (as % of service exports) of 2007 in Pakistan to that in Portugal?
Provide a short and direct response. 0.17. What is the ratio of the Balance of Payment (as % of service exports) of 2008 in Pakistan to that in Portugal?
Make the answer very short. 0.18. What is the ratio of the Balance of Payment (as % of service exports) of 2005 in Panama to that in Philippines?
Your response must be concise. 0.92. What is the ratio of the Balance of Payment (as % of service exports) in 2006 in Panama to that in Philippines?
Your answer should be very brief. 0.75. What is the ratio of the Balance of Payment (as % of service exports) in 2007 in Panama to that in Philippines?
Ensure brevity in your answer.  0.66. What is the ratio of the Balance of Payment (as % of service exports) in 2008 in Panama to that in Philippines?
Keep it short and to the point. 1.27. What is the ratio of the Balance of Payment (as % of service exports) of 2005 in Panama to that in Portugal?
Ensure brevity in your answer.  0.48. What is the ratio of the Balance of Payment (as % of service exports) in 2006 in Panama to that in Portugal?
Offer a very short reply. 0.53. What is the ratio of the Balance of Payment (as % of service exports) in 2007 in Panama to that in Portugal?
Provide a succinct answer. 0.55. What is the ratio of the Balance of Payment (as % of service exports) in 2008 in Panama to that in Portugal?
Your answer should be compact. 0.59. What is the ratio of the Balance of Payment (as % of service exports) of 2005 in Philippines to that in Portugal?
Offer a very short reply. 0.52. What is the ratio of the Balance of Payment (as % of service exports) of 2006 in Philippines to that in Portugal?
Your answer should be compact. 0.7. What is the ratio of the Balance of Payment (as % of service exports) of 2007 in Philippines to that in Portugal?
Offer a very short reply. 0.84. What is the ratio of the Balance of Payment (as % of service exports) of 2008 in Philippines to that in Portugal?
Make the answer very short. 0.47. What is the difference between the highest and the second highest Balance of Payment (as % of service exports) in 2005?
Keep it short and to the point. 13.06. What is the difference between the highest and the second highest Balance of Payment (as % of service exports) of 2006?
Offer a terse response. 16.69. What is the difference between the highest and the second highest Balance of Payment (as % of service exports) in 2007?
Make the answer very short. 18.13. What is the difference between the highest and the second highest Balance of Payment (as % of service exports) of 2008?
Offer a very short reply. 16.72. What is the difference between the highest and the lowest Balance of Payment (as % of service exports) in 2005?
Ensure brevity in your answer.  58.93. What is the difference between the highest and the lowest Balance of Payment (as % of service exports) of 2006?
Offer a terse response. 55.17. What is the difference between the highest and the lowest Balance of Payment (as % of service exports) of 2007?
Your answer should be very brief. 54.54. What is the difference between the highest and the lowest Balance of Payment (as % of service exports) in 2008?
Offer a terse response. 51.47. 